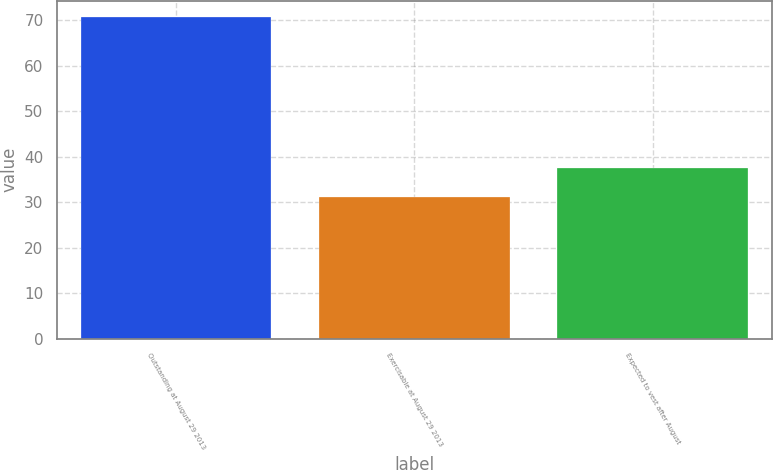Convert chart. <chart><loc_0><loc_0><loc_500><loc_500><bar_chart><fcel>Outstanding at August 29 2013<fcel>Exercisable at August 29 2013<fcel>Expected to vest after August<nl><fcel>70.8<fcel>31.2<fcel>37.6<nl></chart> 